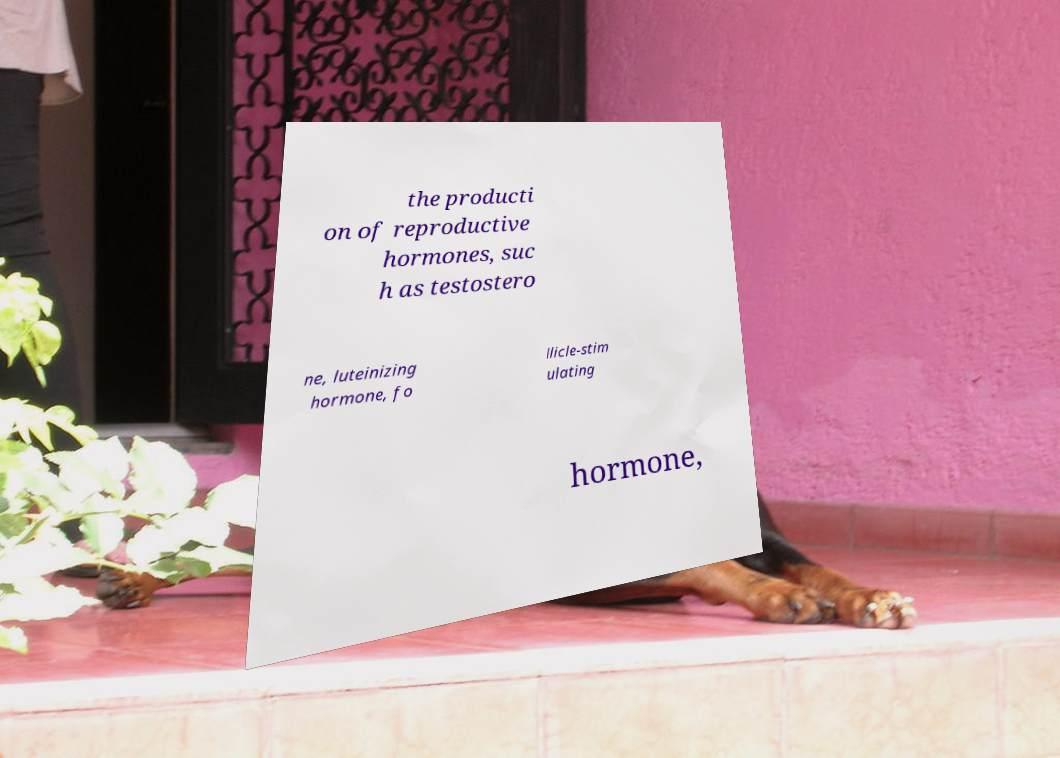Could you extract and type out the text from this image? the producti on of reproductive hormones, suc h as testostero ne, luteinizing hormone, fo llicle-stim ulating hormone, 